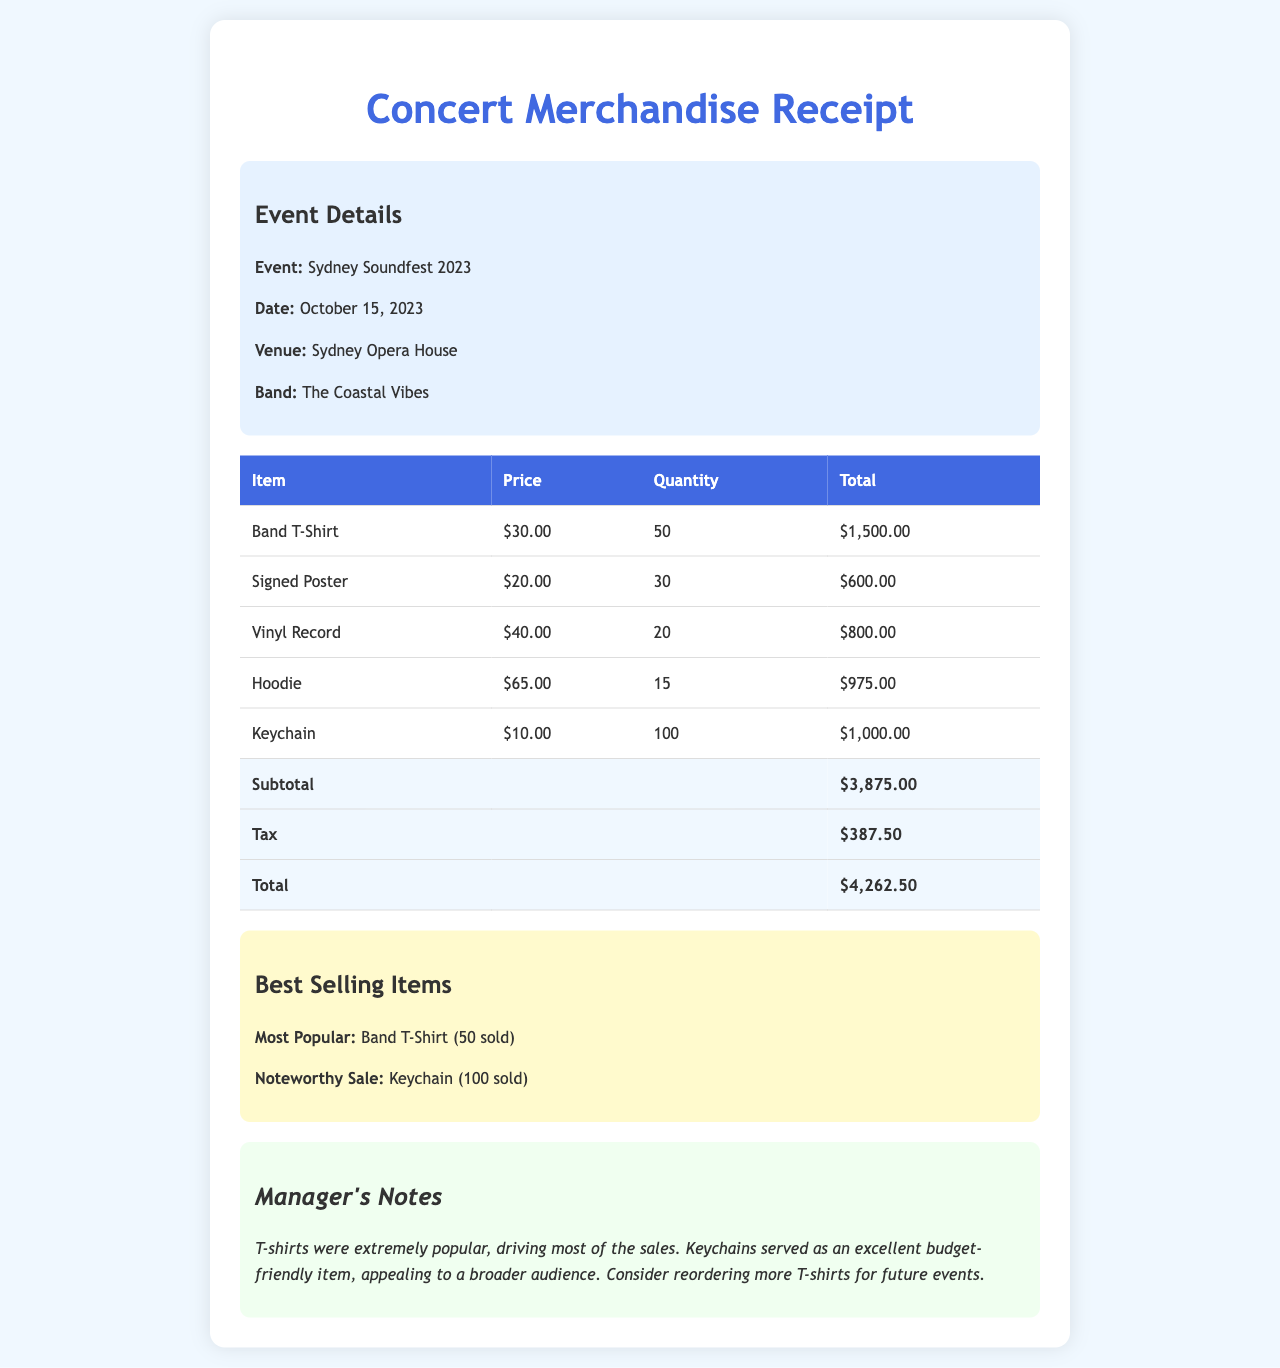what is the date of the event? The event is held on October 15, 2023, as indicated in the document.
Answer: October 15, 2023 what is the total amount of sales? The total sales amount is listed at the bottom of the receipt, which combines the subtotal and tax.
Answer: $4,262.50 how many Band T-Shirts were sold? The document states that 50 Band T-Shirts were sold, which is shown in the merchandise table.
Answer: 50 what item generated the highest revenue? The item with the highest revenue can be calculated from the total sales for each item; the Band T-Shirt totals $1,500, which is the highest.
Answer: Band T-Shirt how much tax was collected? The tax amount is specified in the total sales summary section of the receipt.
Answer: $387.50 what is the venue for the concert? The venue information is provided in the event details section of the document.
Answer: Sydney Opera House how many Keychains were sold? The total quantity sold for Keychains is explicitly mentioned in the merchandise table.
Answer: 100 who is the band performing at the gig? The band name is listed in the event details section.
Answer: The Coastal Vibes what is noted as the most popular item? The document highlights the Band T-Shirt as the most popular item based on sales.
Answer: Band T-Shirt 